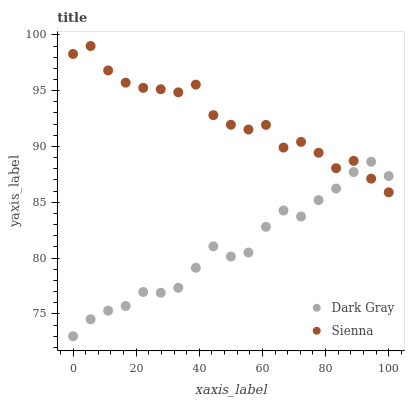Does Dark Gray have the minimum area under the curve?
Answer yes or no. Yes. Does Sienna have the maximum area under the curve?
Answer yes or no. Yes. Does Sienna have the minimum area under the curve?
Answer yes or no. No. Is Dark Gray the smoothest?
Answer yes or no. Yes. Is Sienna the roughest?
Answer yes or no. Yes. Is Sienna the smoothest?
Answer yes or no. No. Does Dark Gray have the lowest value?
Answer yes or no. Yes. Does Sienna have the lowest value?
Answer yes or no. No. Does Sienna have the highest value?
Answer yes or no. Yes. Does Dark Gray intersect Sienna?
Answer yes or no. Yes. Is Dark Gray less than Sienna?
Answer yes or no. No. Is Dark Gray greater than Sienna?
Answer yes or no. No. 